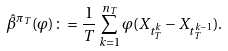Convert formula to latex. <formula><loc_0><loc_0><loc_500><loc_500>\hat { \beta } ^ { \pi _ { T } } ( \varphi ) \colon = \frac { 1 } { T } \sum _ { k = 1 } ^ { n _ { T } } \varphi ( X _ { t ^ { k } _ { T } } - X _ { t ^ { k - 1 } _ { T } } ) .</formula> 